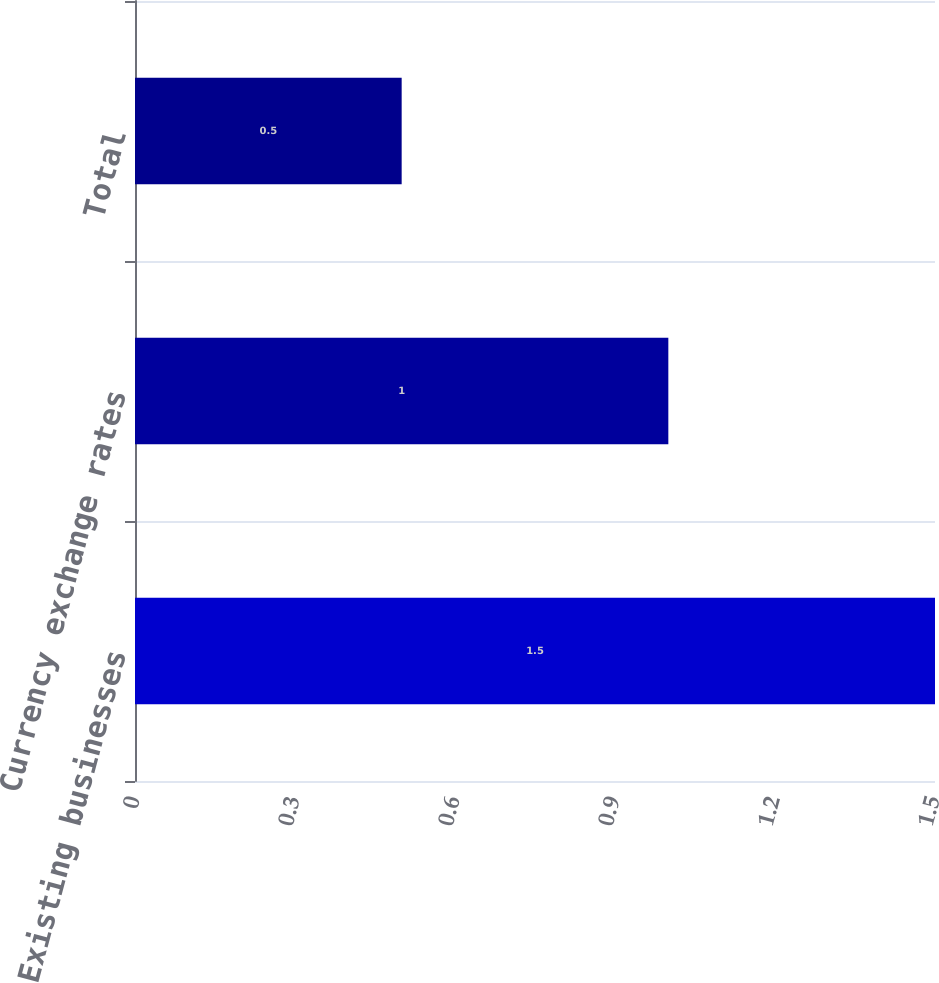Convert chart to OTSL. <chart><loc_0><loc_0><loc_500><loc_500><bar_chart><fcel>Existing businesses<fcel>Currency exchange rates<fcel>Total<nl><fcel>1.5<fcel>1<fcel>0.5<nl></chart> 